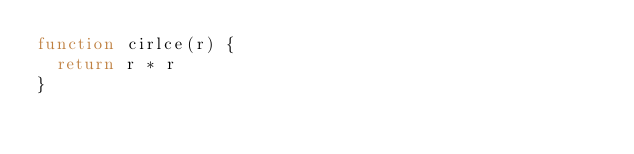Convert code to text. <code><loc_0><loc_0><loc_500><loc_500><_JavaScript_>function cirlce(r) {
  return r * r
}</code> 